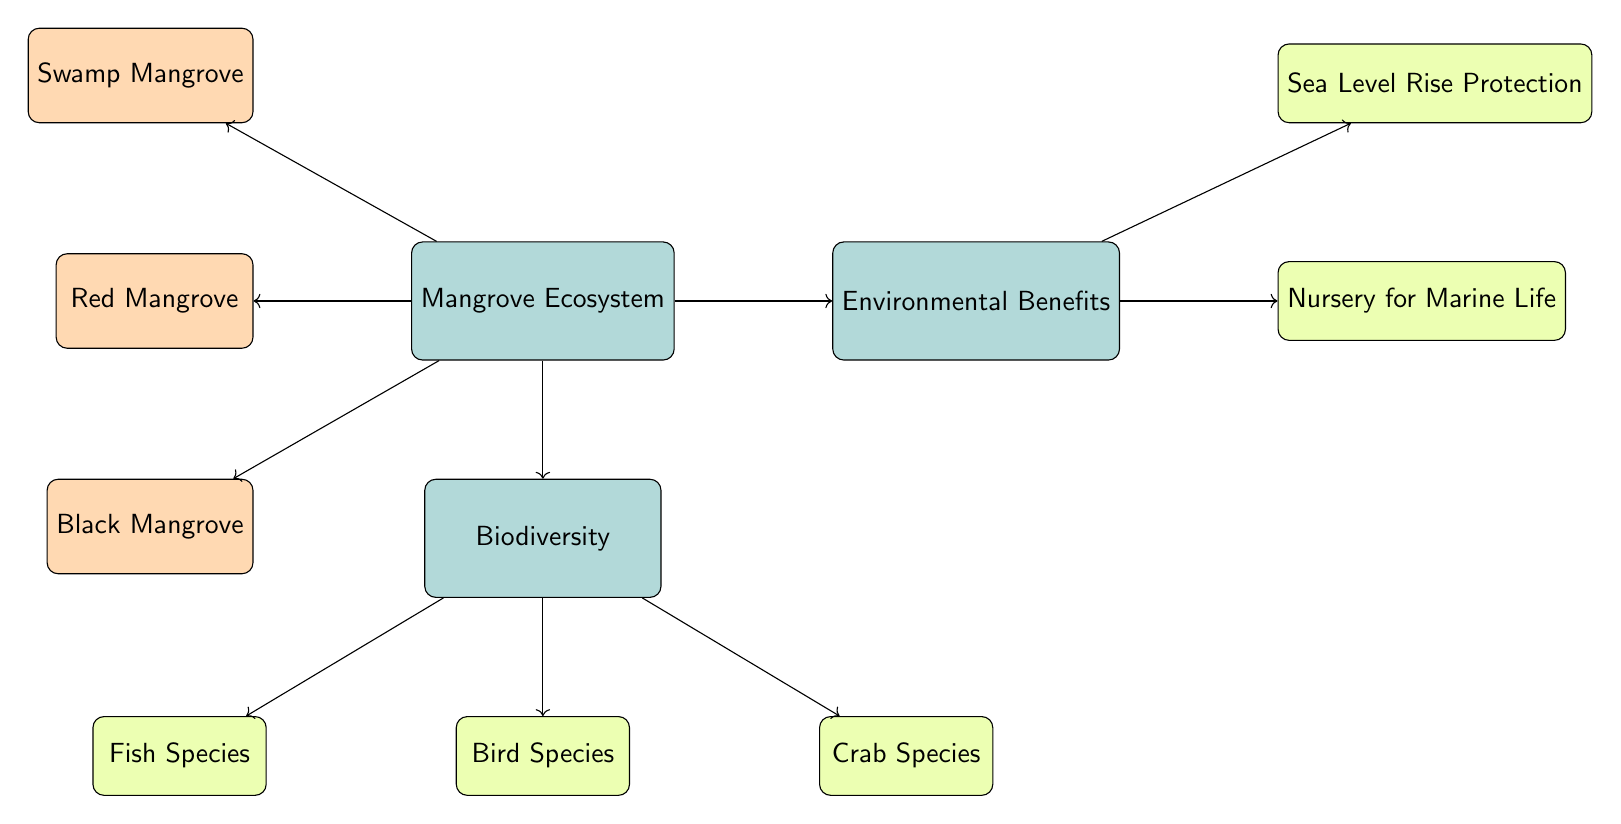What are the types of mangroves shown in the diagram? The diagram distinctly shows three types of mangroves: Swamp Mangrove, Red Mangrove, and Black Mangrove. These types are identified as sub-nodes directly connected to the main node "Mangrove Ecosystem."
Answer: Swamp Mangrove, Red Mangrove, Black Mangrove How many species of fish are included in the biodiversity? The diagram indicates that there is one mention of fish species listed as a leaf node under the "Biodiversity" node, implying the presence of fish species.
Answer: 1 What specific environmental benefit is provided for sea level rise? The diagram states that "Sea Level Rise Protection" is one of the benefits derived from the Mangrove Ecosystem and is presented as a leaf node connected to the "Environmental Benefits" node.
Answer: Sea Level Rise Protection Which type of mangrove is listed first in the diagram? In the diagram, the first mangrove type listed above the "Mangrove Ecosystem" node is "Swamp Mangrove," as the nodes are arranged spatially with Swamp Mangrove at the upper left position.
Answer: Swamp Mangrove What biodiversity elements are included besides fish species? The diagram shows two additional biodiversity elements: "Bird Species" and "Crab Species," which are also leaf nodes under the "Biodiversity" node.
Answer: Bird Species, Crab Species How many connections lead from the "Mangrove Ecosystem" to other nodes? The "Mangrove Ecosystem" node has four connections leading to other nodes: to the biodiversity, swamp, red, and black mangrove, thus making a total of four lines connecting it to other elements in the diagram.
Answer: 4 What is the relationship depicted between the "Mangrove Ecosystem" and "Biodiversity"? The relationship is indicated by an arrow labeled "Supports," showing that the Mangrove Ecosystem supports the biodiversity depicted in the diagram, establishing a direct link between the two.
Answer: Supports Which leaf node represents the nursery for marine life? The leaf node labeled "Nursery for Marine Life" is directly connected to the "Environmental Benefits" node, indicating that this specific benefit refers to the nursery aspect for marine species.
Answer: Nursery for Marine Life 